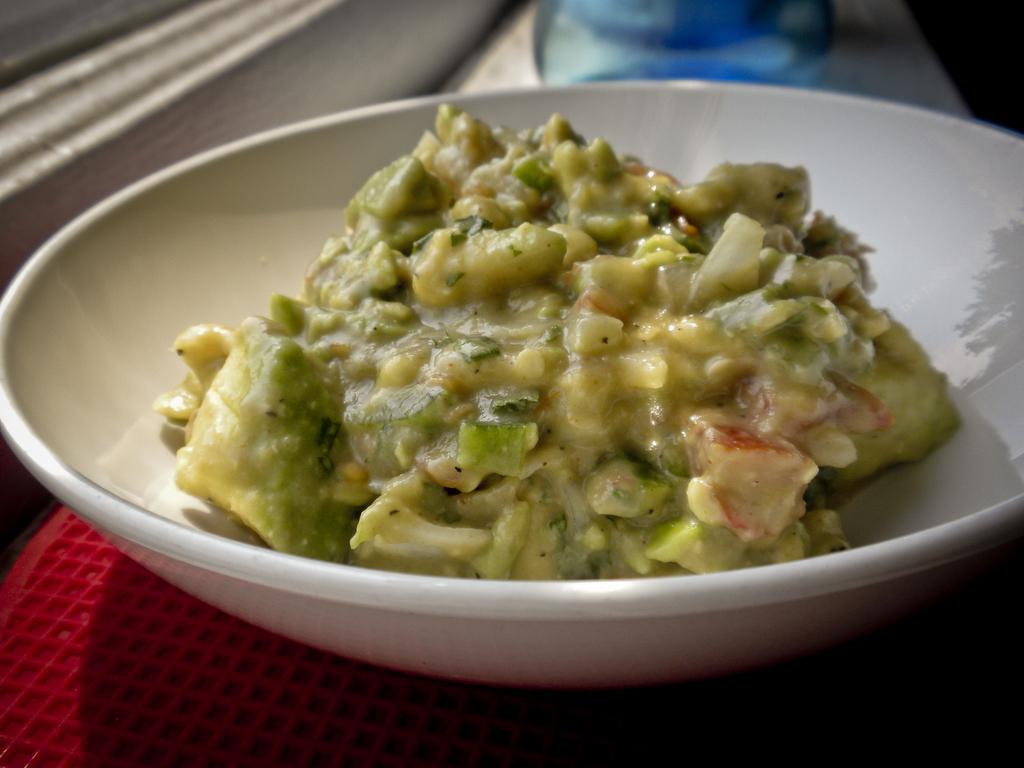What is the main subject of the image? There is a food item in the image. How is the food item contained in the image? The food item is in a bowl. Where is the bowl placed in the image? The bowl is placed on a surface. What time of day is it in the image, and how many pigs are visible? The time of day is not mentioned in the image, and there are no pigs visible. 